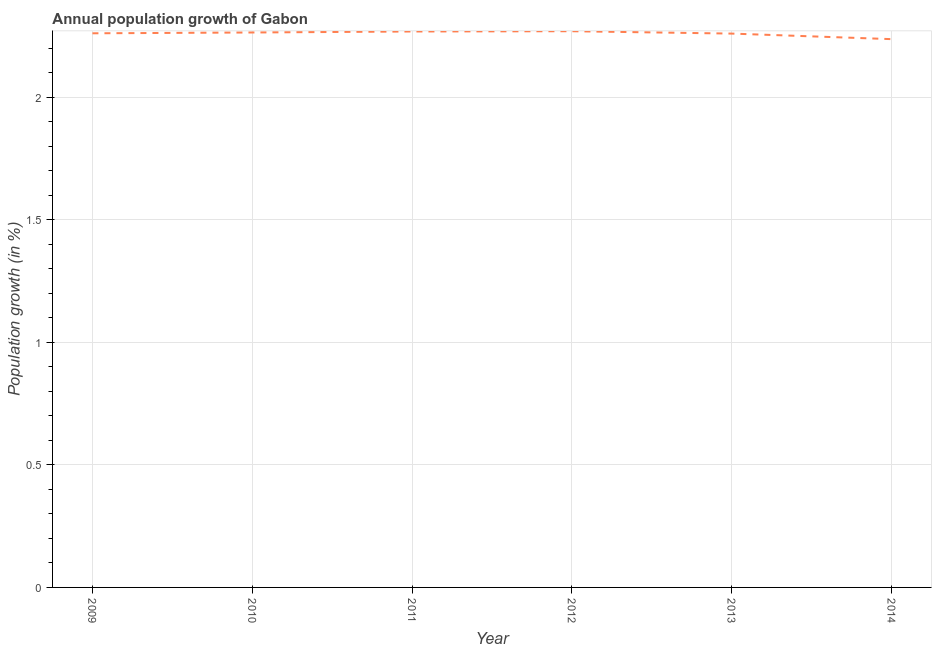What is the population growth in 2011?
Provide a succinct answer. 2.27. Across all years, what is the maximum population growth?
Keep it short and to the point. 2.27. Across all years, what is the minimum population growth?
Your answer should be compact. 2.24. In which year was the population growth maximum?
Give a very brief answer. 2012. In which year was the population growth minimum?
Offer a terse response. 2014. What is the sum of the population growth?
Give a very brief answer. 13.55. What is the difference between the population growth in 2011 and 2014?
Your answer should be very brief. 0.03. What is the average population growth per year?
Your response must be concise. 2.26. What is the median population growth?
Keep it short and to the point. 2.26. In how many years, is the population growth greater than 0.6 %?
Provide a short and direct response. 6. What is the ratio of the population growth in 2013 to that in 2014?
Your response must be concise. 1.01. Is the population growth in 2009 less than that in 2010?
Your answer should be compact. Yes. Is the difference between the population growth in 2009 and 2010 greater than the difference between any two years?
Your response must be concise. No. What is the difference between the highest and the second highest population growth?
Provide a succinct answer. 0. Is the sum of the population growth in 2010 and 2012 greater than the maximum population growth across all years?
Offer a very short reply. Yes. What is the difference between the highest and the lowest population growth?
Your response must be concise. 0.03. Does the population growth monotonically increase over the years?
Your answer should be very brief. No. What is the difference between two consecutive major ticks on the Y-axis?
Ensure brevity in your answer.  0.5. Does the graph contain any zero values?
Offer a very short reply. No. Does the graph contain grids?
Your answer should be compact. Yes. What is the title of the graph?
Offer a terse response. Annual population growth of Gabon. What is the label or title of the X-axis?
Your answer should be compact. Year. What is the label or title of the Y-axis?
Offer a very short reply. Population growth (in %). What is the Population growth (in %) in 2009?
Offer a terse response. 2.26. What is the Population growth (in %) in 2010?
Provide a short and direct response. 2.26. What is the Population growth (in %) of 2011?
Give a very brief answer. 2.27. What is the Population growth (in %) in 2012?
Provide a short and direct response. 2.27. What is the Population growth (in %) of 2013?
Your answer should be very brief. 2.26. What is the Population growth (in %) in 2014?
Your answer should be compact. 2.24. What is the difference between the Population growth (in %) in 2009 and 2010?
Provide a short and direct response. -0. What is the difference between the Population growth (in %) in 2009 and 2011?
Provide a succinct answer. -0.01. What is the difference between the Population growth (in %) in 2009 and 2012?
Provide a short and direct response. -0.01. What is the difference between the Population growth (in %) in 2009 and 2013?
Make the answer very short. 0. What is the difference between the Population growth (in %) in 2009 and 2014?
Ensure brevity in your answer.  0.02. What is the difference between the Population growth (in %) in 2010 and 2011?
Make the answer very short. -0. What is the difference between the Population growth (in %) in 2010 and 2012?
Your answer should be compact. -0.01. What is the difference between the Population growth (in %) in 2010 and 2013?
Your response must be concise. 0. What is the difference between the Population growth (in %) in 2010 and 2014?
Your answer should be very brief. 0.03. What is the difference between the Population growth (in %) in 2011 and 2012?
Make the answer very short. -0. What is the difference between the Population growth (in %) in 2011 and 2013?
Ensure brevity in your answer.  0.01. What is the difference between the Population growth (in %) in 2011 and 2014?
Ensure brevity in your answer.  0.03. What is the difference between the Population growth (in %) in 2012 and 2013?
Offer a terse response. 0.01. What is the difference between the Population growth (in %) in 2012 and 2014?
Provide a short and direct response. 0.03. What is the difference between the Population growth (in %) in 2013 and 2014?
Provide a succinct answer. 0.02. What is the ratio of the Population growth (in %) in 2009 to that in 2010?
Offer a terse response. 1. What is the ratio of the Population growth (in %) in 2009 to that in 2012?
Your response must be concise. 1. What is the ratio of the Population growth (in %) in 2009 to that in 2014?
Provide a succinct answer. 1.01. What is the ratio of the Population growth (in %) in 2011 to that in 2013?
Your answer should be very brief. 1. What is the ratio of the Population growth (in %) in 2012 to that in 2013?
Your answer should be very brief. 1. What is the ratio of the Population growth (in %) in 2012 to that in 2014?
Provide a succinct answer. 1.01. What is the ratio of the Population growth (in %) in 2013 to that in 2014?
Provide a short and direct response. 1.01. 